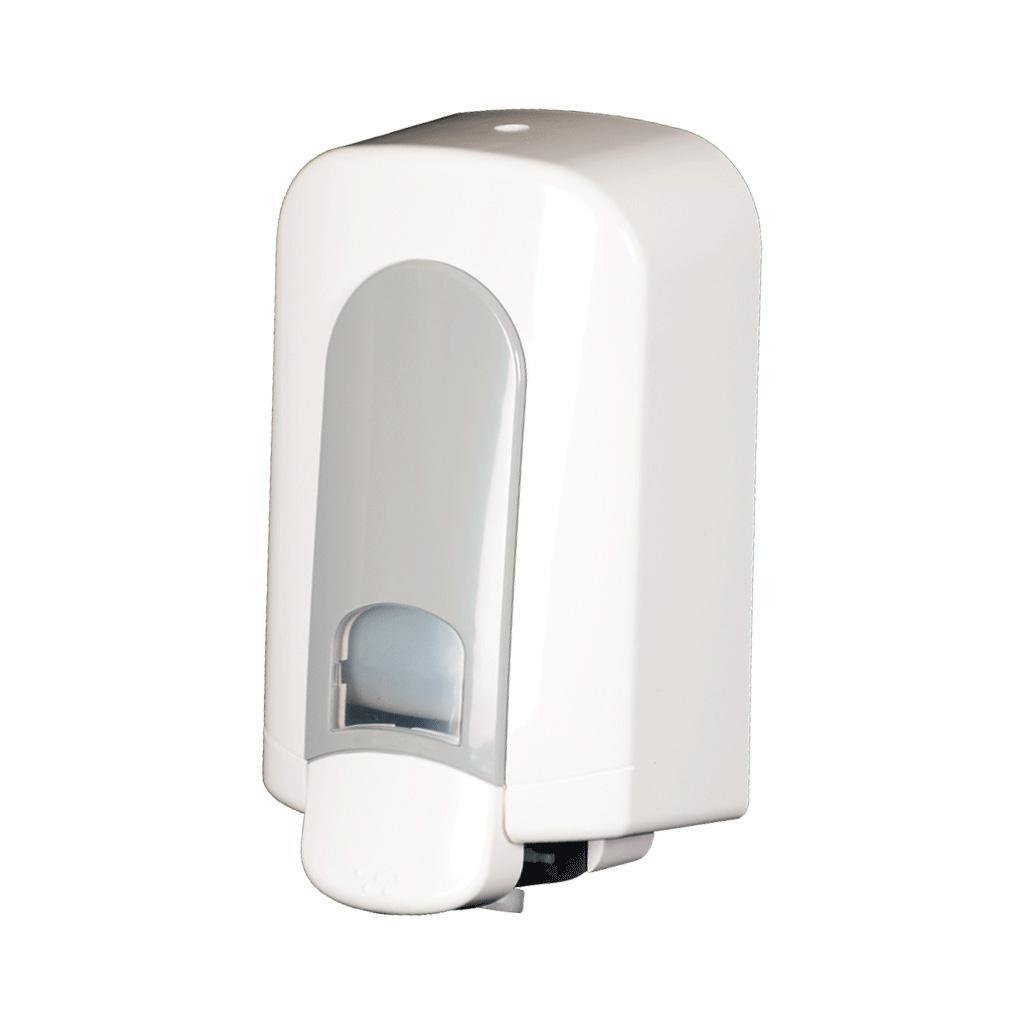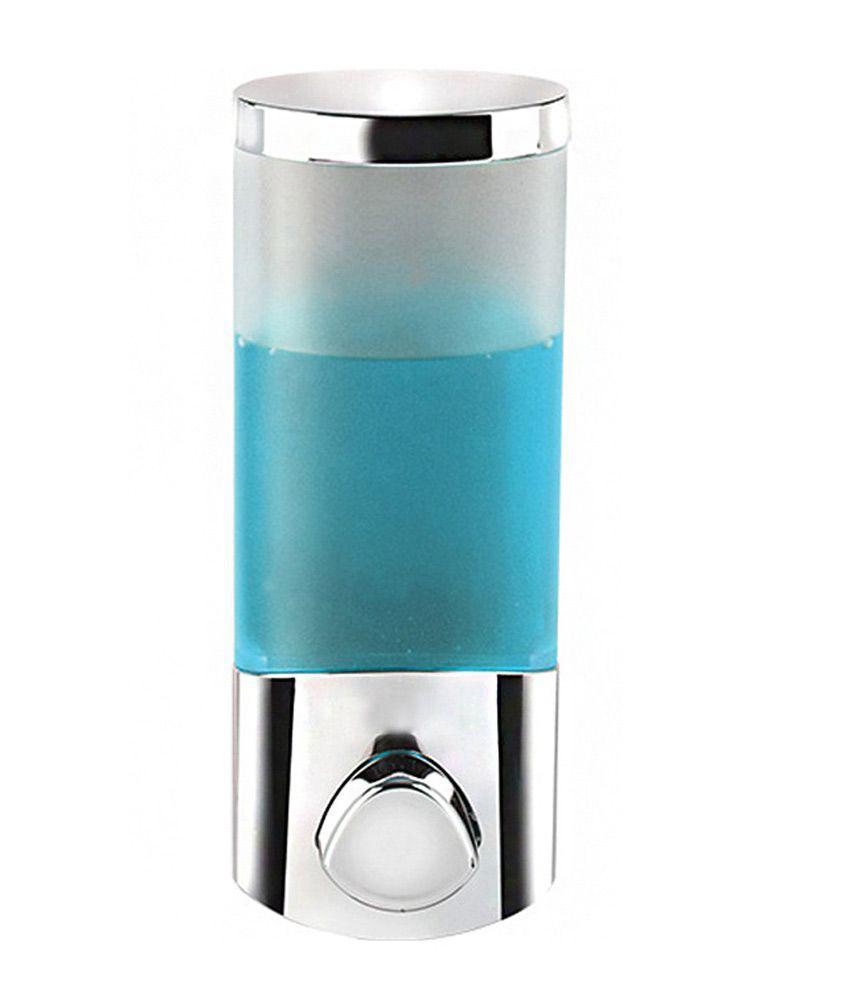The first image is the image on the left, the second image is the image on the right. Analyze the images presented: Is the assertion "One dispenser is cylinder shaped with a pump at the top." valid? Answer yes or no. No. 